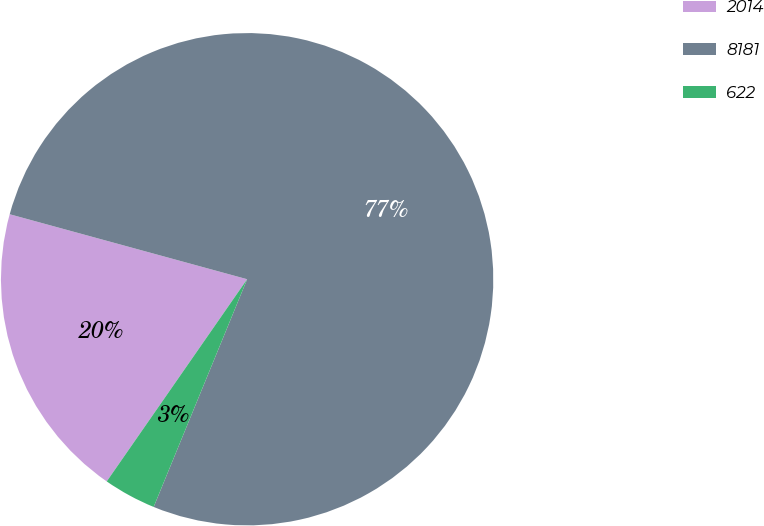Convert chart. <chart><loc_0><loc_0><loc_500><loc_500><pie_chart><fcel>2014<fcel>8181<fcel>622<nl><fcel>19.59%<fcel>76.94%<fcel>3.46%<nl></chart> 